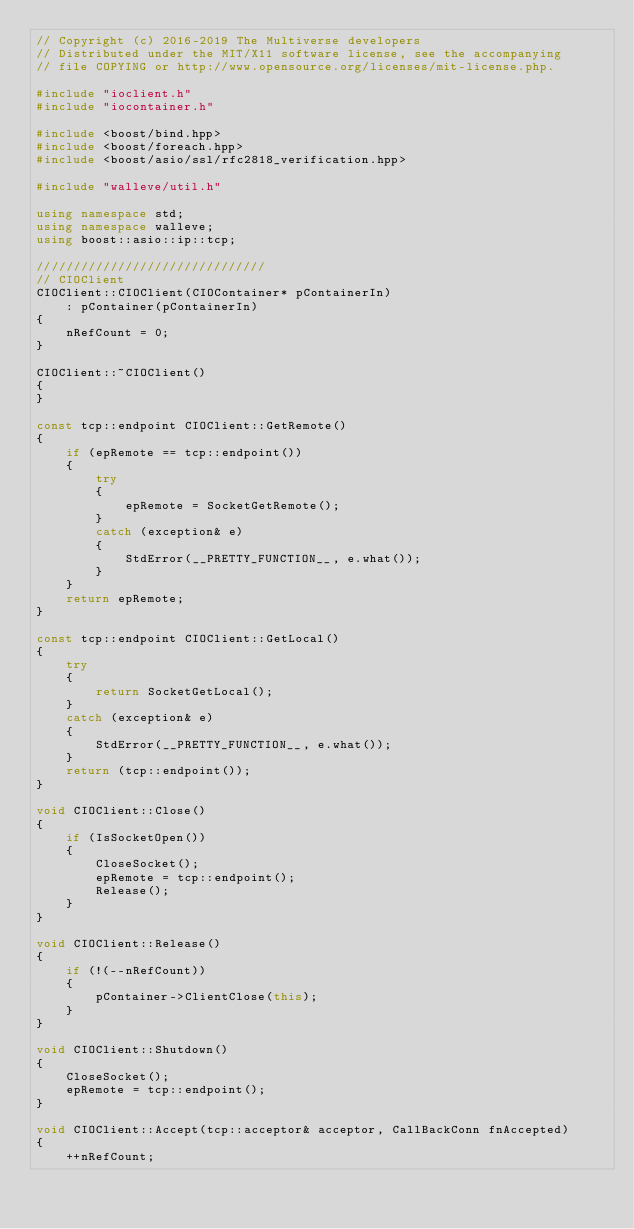Convert code to text. <code><loc_0><loc_0><loc_500><loc_500><_C++_>// Copyright (c) 2016-2019 The Multiverse developers
// Distributed under the MIT/X11 software license, see the accompanying
// file COPYING or http://www.opensource.org/licenses/mit-license.php.

#include "ioclient.h"
#include "iocontainer.h"

#include <boost/bind.hpp>
#include <boost/foreach.hpp>
#include <boost/asio/ssl/rfc2818_verification.hpp>

#include "walleve/util.h"

using namespace std;
using namespace walleve;
using boost::asio::ip::tcp;

///////////////////////////////
// CIOClient
CIOClient::CIOClient(CIOContainer* pContainerIn)
    : pContainer(pContainerIn)
{
    nRefCount = 0;
}

CIOClient::~CIOClient()
{
}

const tcp::endpoint CIOClient::GetRemote()
{
    if (epRemote == tcp::endpoint())
    {
        try
        {
            epRemote = SocketGetRemote();
        }
        catch (exception& e)
        {
            StdError(__PRETTY_FUNCTION__, e.what());
        }
    }
    return epRemote;
}

const tcp::endpoint CIOClient::GetLocal()
{
    try
    {
        return SocketGetLocal();
    }
    catch (exception& e)
    {
        StdError(__PRETTY_FUNCTION__, e.what());
    }
    return (tcp::endpoint());
}

void CIOClient::Close()
{
    if (IsSocketOpen())
    {
        CloseSocket();
        epRemote = tcp::endpoint();
        Release();
    }
}

void CIOClient::Release()
{
    if (!(--nRefCount))
    {
        pContainer->ClientClose(this);
    }
}

void CIOClient::Shutdown()
{
    CloseSocket();
    epRemote = tcp::endpoint();
}

void CIOClient::Accept(tcp::acceptor& acceptor, CallBackConn fnAccepted)
{
    ++nRefCount;</code> 